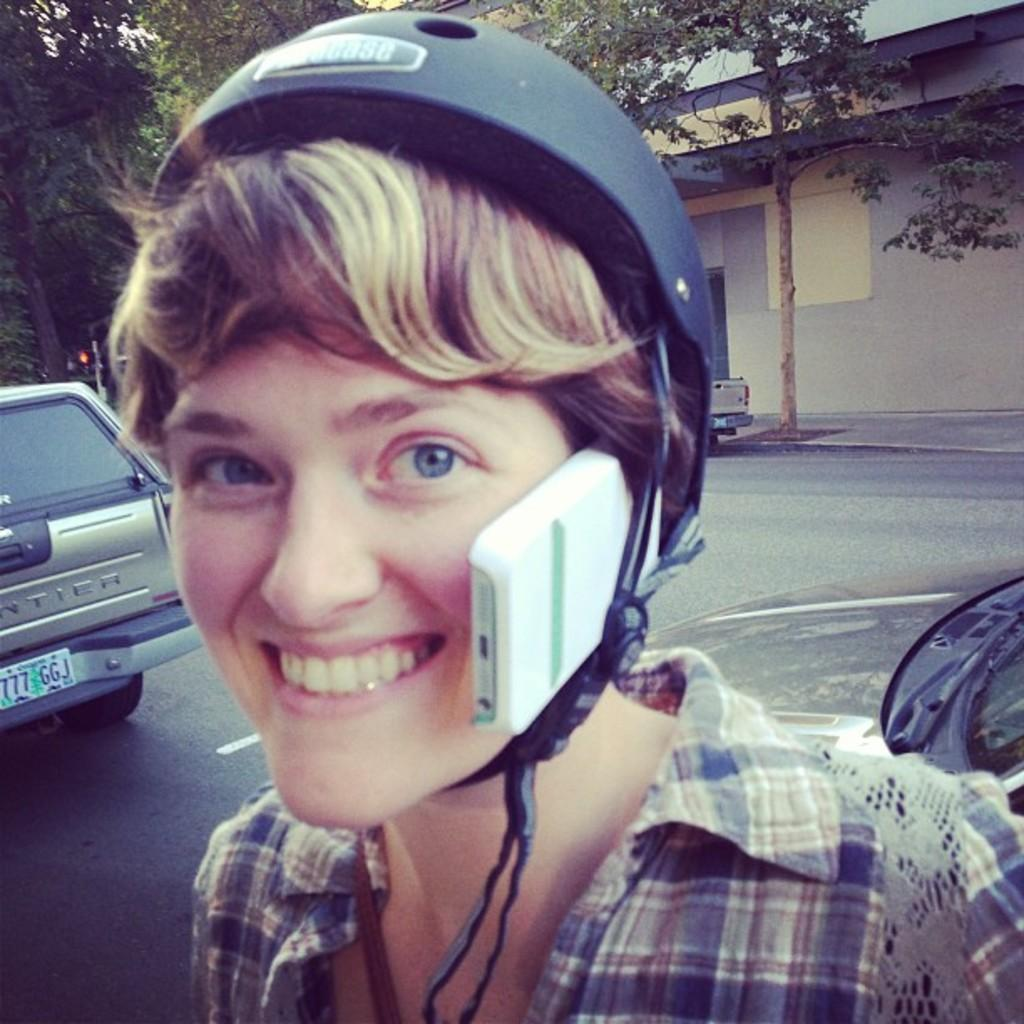What can be seen in the image? There is a person in the image, and they are wearing a helmet. What is the person holding in the helmet? The person is holding a mobile in the helmet. What is located on the left side of the image? There is a vehicle on the left side of the image. What type of surface is visible in the image? There is a road visible in the image. What can be seen in the background of the image? There are trees and a building in the background of the image. What type of fruit can be seen hanging from the trees in the background? There is no fruit visible in the image, and therefore no such activity can be observed. 